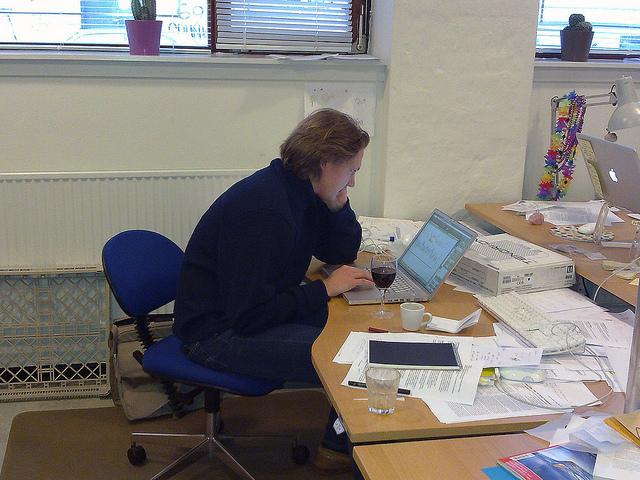Is the laptop on?
Keep it brief. Yes. Where is the red wine?
Be succinct. In glass. Is the work area neatly arranged?
Quick response, please. No. What color is the  keyboard?
Short answer required. Silver. What is outside the window?
Give a very brief answer. City. 